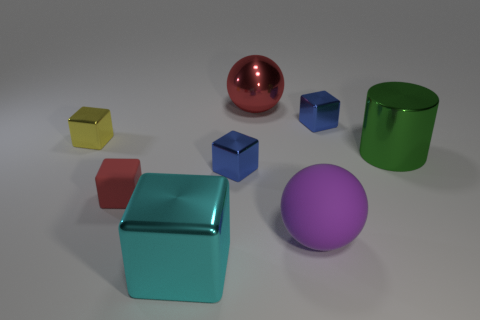Subtract all big cyan metallic blocks. How many blocks are left? 4 Subtract all purple spheres. How many blue cubes are left? 2 Subtract all blue cubes. How many cubes are left? 3 Subtract 3 blocks. How many blocks are left? 2 Add 1 yellow objects. How many objects exist? 9 Subtract all brown cubes. Subtract all blue balls. How many cubes are left? 5 Subtract all small rubber balls. Subtract all yellow metal cubes. How many objects are left? 7 Add 1 green cylinders. How many green cylinders are left? 2 Add 7 red rubber objects. How many red rubber objects exist? 8 Subtract 0 gray cylinders. How many objects are left? 8 